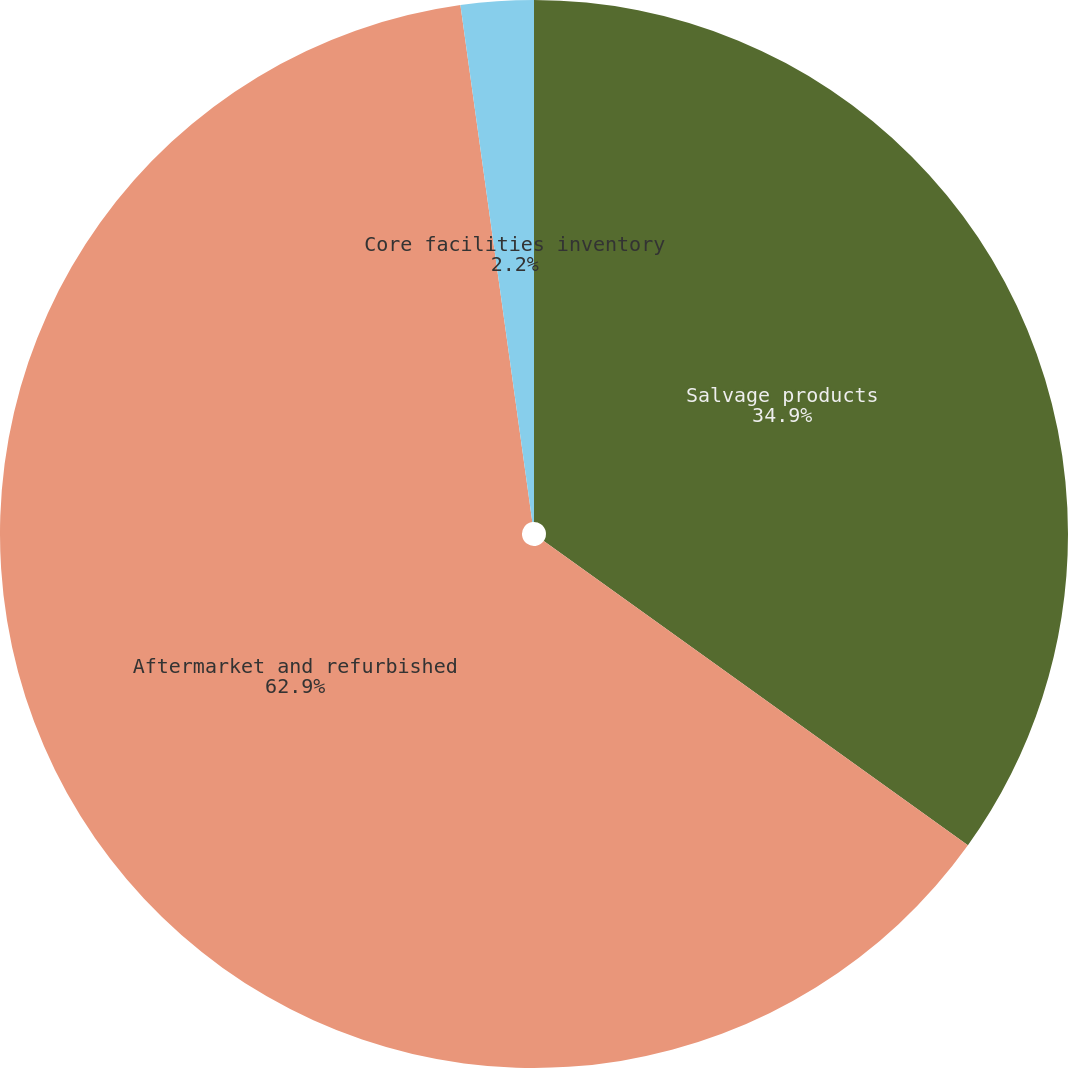Convert chart. <chart><loc_0><loc_0><loc_500><loc_500><pie_chart><fcel>Salvage products<fcel>Aftermarket and refurbished<fcel>Core facilities inventory<nl><fcel>34.9%<fcel>62.89%<fcel>2.2%<nl></chart> 